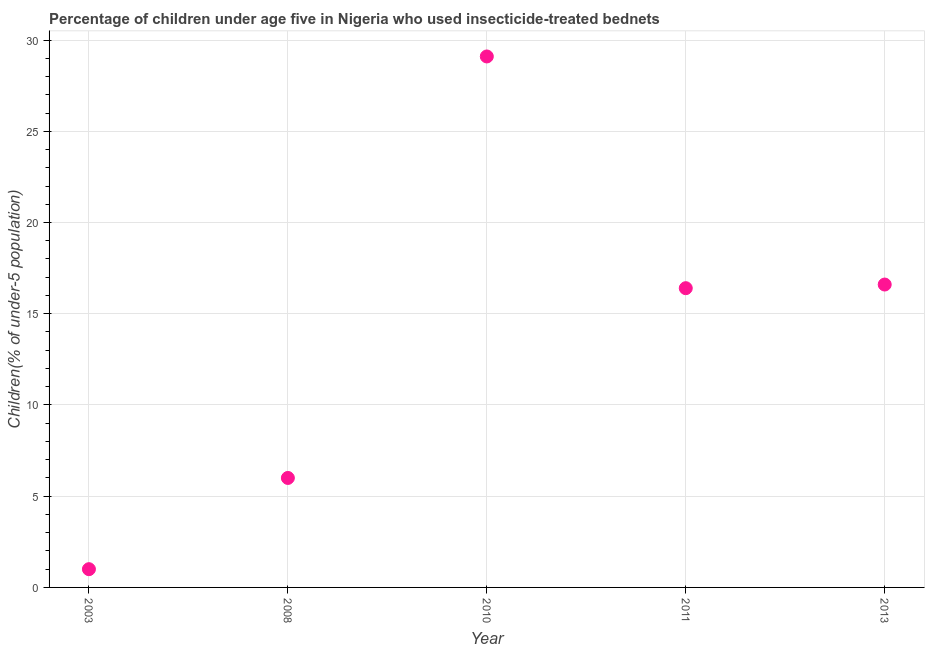What is the percentage of children who use of insecticide-treated bed nets in 2011?
Offer a very short reply. 16.4. Across all years, what is the maximum percentage of children who use of insecticide-treated bed nets?
Your response must be concise. 29.1. Across all years, what is the minimum percentage of children who use of insecticide-treated bed nets?
Offer a very short reply. 1. In which year was the percentage of children who use of insecticide-treated bed nets maximum?
Your response must be concise. 2010. In which year was the percentage of children who use of insecticide-treated bed nets minimum?
Provide a succinct answer. 2003. What is the sum of the percentage of children who use of insecticide-treated bed nets?
Your answer should be very brief. 69.1. What is the difference between the percentage of children who use of insecticide-treated bed nets in 2008 and 2013?
Provide a short and direct response. -10.6. What is the average percentage of children who use of insecticide-treated bed nets per year?
Provide a succinct answer. 13.82. What is the median percentage of children who use of insecticide-treated bed nets?
Your answer should be compact. 16.4. Do a majority of the years between 2011 and 2008 (inclusive) have percentage of children who use of insecticide-treated bed nets greater than 26 %?
Keep it short and to the point. No. What is the ratio of the percentage of children who use of insecticide-treated bed nets in 2003 to that in 2010?
Keep it short and to the point. 0.03. Is the difference between the percentage of children who use of insecticide-treated bed nets in 2003 and 2010 greater than the difference between any two years?
Ensure brevity in your answer.  Yes. What is the difference between the highest and the second highest percentage of children who use of insecticide-treated bed nets?
Make the answer very short. 12.5. Is the sum of the percentage of children who use of insecticide-treated bed nets in 2011 and 2013 greater than the maximum percentage of children who use of insecticide-treated bed nets across all years?
Your answer should be compact. Yes. What is the difference between the highest and the lowest percentage of children who use of insecticide-treated bed nets?
Your answer should be compact. 28.1. Does the percentage of children who use of insecticide-treated bed nets monotonically increase over the years?
Offer a terse response. No. What is the difference between two consecutive major ticks on the Y-axis?
Give a very brief answer. 5. Does the graph contain any zero values?
Your answer should be compact. No. What is the title of the graph?
Provide a short and direct response. Percentage of children under age five in Nigeria who used insecticide-treated bednets. What is the label or title of the Y-axis?
Your response must be concise. Children(% of under-5 population). What is the Children(% of under-5 population) in 2008?
Offer a very short reply. 6. What is the Children(% of under-5 population) in 2010?
Offer a terse response. 29.1. What is the difference between the Children(% of under-5 population) in 2003 and 2008?
Provide a succinct answer. -5. What is the difference between the Children(% of under-5 population) in 2003 and 2010?
Ensure brevity in your answer.  -28.1. What is the difference between the Children(% of under-5 population) in 2003 and 2011?
Offer a terse response. -15.4. What is the difference between the Children(% of under-5 population) in 2003 and 2013?
Your response must be concise. -15.6. What is the difference between the Children(% of under-5 population) in 2008 and 2010?
Make the answer very short. -23.1. What is the difference between the Children(% of under-5 population) in 2008 and 2011?
Your response must be concise. -10.4. What is the difference between the Children(% of under-5 population) in 2010 and 2013?
Your answer should be very brief. 12.5. What is the ratio of the Children(% of under-5 population) in 2003 to that in 2008?
Provide a short and direct response. 0.17. What is the ratio of the Children(% of under-5 population) in 2003 to that in 2010?
Offer a terse response. 0.03. What is the ratio of the Children(% of under-5 population) in 2003 to that in 2011?
Make the answer very short. 0.06. What is the ratio of the Children(% of under-5 population) in 2008 to that in 2010?
Your response must be concise. 0.21. What is the ratio of the Children(% of under-5 population) in 2008 to that in 2011?
Your response must be concise. 0.37. What is the ratio of the Children(% of under-5 population) in 2008 to that in 2013?
Offer a very short reply. 0.36. What is the ratio of the Children(% of under-5 population) in 2010 to that in 2011?
Make the answer very short. 1.77. What is the ratio of the Children(% of under-5 population) in 2010 to that in 2013?
Keep it short and to the point. 1.75. 